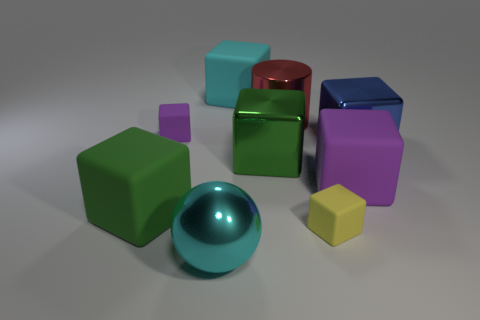How many other things are the same color as the large shiny cylinder?
Provide a short and direct response. 0. What number of small purple objects are the same shape as the yellow object?
Provide a succinct answer. 1. There is a big thing that is the same color as the large ball; what material is it?
Ensure brevity in your answer.  Rubber. What number of objects are either large purple metallic cylinders or big cubes right of the big red cylinder?
Offer a very short reply. 2. What is the blue cube made of?
Your answer should be compact. Metal. What is the material of the yellow object that is the same shape as the large purple rubber object?
Offer a terse response. Rubber. There is a small matte object behind the purple thing to the right of the yellow rubber block; what color is it?
Offer a terse response. Purple. How many rubber things are either large purple balls or large blue things?
Provide a short and direct response. 0. Do the cylinder and the yellow block have the same material?
Provide a succinct answer. No. There is a thing in front of the matte cube that is in front of the green rubber cube; what is its material?
Your answer should be compact. Metal. 